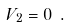Convert formula to latex. <formula><loc_0><loc_0><loc_500><loc_500>V _ { 2 } = 0 \ .</formula> 